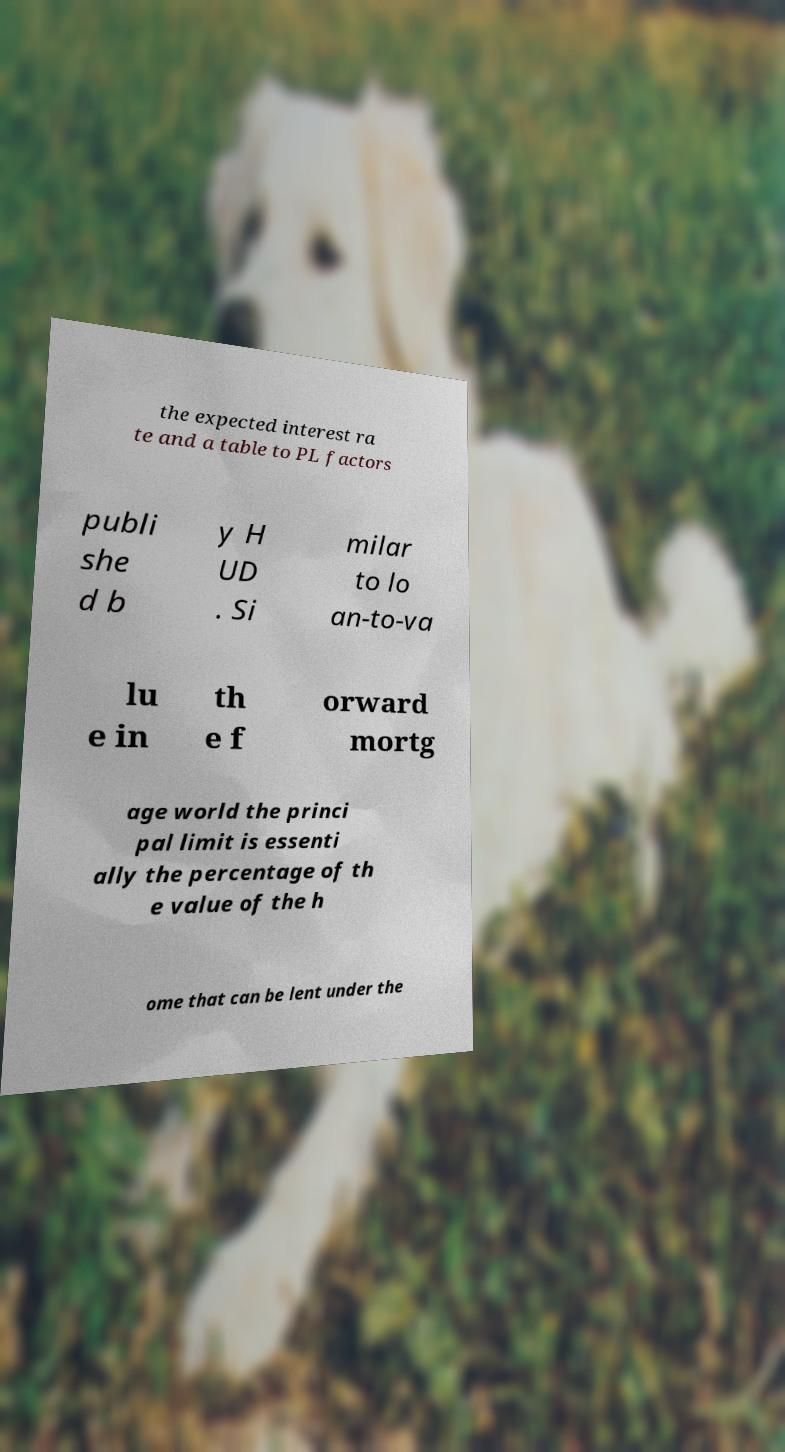Please read and relay the text visible in this image. What does it say? the expected interest ra te and a table to PL factors publi she d b y H UD . Si milar to lo an-to-va lu e in th e f orward mortg age world the princi pal limit is essenti ally the percentage of th e value of the h ome that can be lent under the 